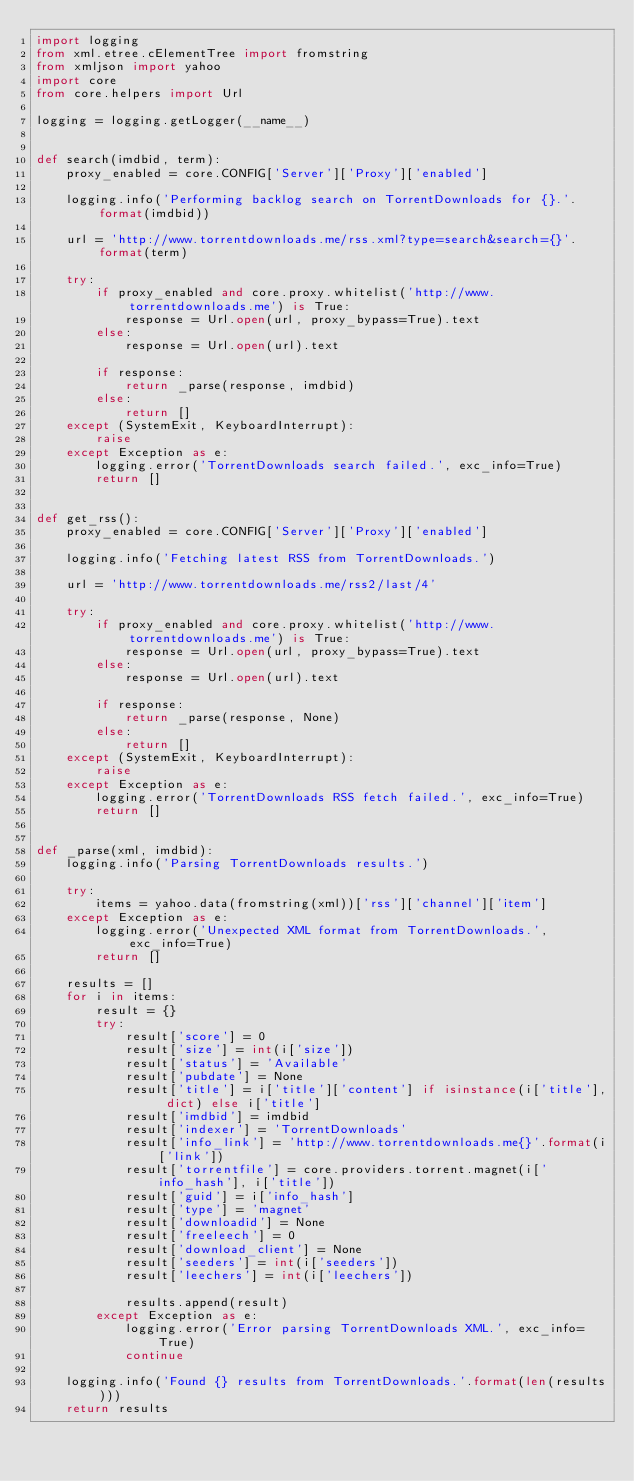<code> <loc_0><loc_0><loc_500><loc_500><_Python_>import logging
from xml.etree.cElementTree import fromstring
from xmljson import yahoo
import core
from core.helpers import Url

logging = logging.getLogger(__name__)


def search(imdbid, term):
    proxy_enabled = core.CONFIG['Server']['Proxy']['enabled']

    logging.info('Performing backlog search on TorrentDownloads for {}.'.format(imdbid))

    url = 'http://www.torrentdownloads.me/rss.xml?type=search&search={}'.format(term)

    try:
        if proxy_enabled and core.proxy.whitelist('http://www.torrentdownloads.me') is True:
            response = Url.open(url, proxy_bypass=True).text
        else:
            response = Url.open(url).text

        if response:
            return _parse(response, imdbid)
        else:
            return []
    except (SystemExit, KeyboardInterrupt):
        raise
    except Exception as e:
        logging.error('TorrentDownloads search failed.', exc_info=True)
        return []


def get_rss():
    proxy_enabled = core.CONFIG['Server']['Proxy']['enabled']

    logging.info('Fetching latest RSS from TorrentDownloads.')

    url = 'http://www.torrentdownloads.me/rss2/last/4'

    try:
        if proxy_enabled and core.proxy.whitelist('http://www.torrentdownloads.me') is True:
            response = Url.open(url, proxy_bypass=True).text
        else:
            response = Url.open(url).text

        if response:
            return _parse(response, None)
        else:
            return []
    except (SystemExit, KeyboardInterrupt):
        raise
    except Exception as e:
        logging.error('TorrentDownloads RSS fetch failed.', exc_info=True)
        return []


def _parse(xml, imdbid):
    logging.info('Parsing TorrentDownloads results.')

    try:
        items = yahoo.data(fromstring(xml))['rss']['channel']['item']
    except Exception as e:
        logging.error('Unexpected XML format from TorrentDownloads.', exc_info=True)
        return []

    results = []
    for i in items:
        result = {}
        try:
            result['score'] = 0
            result['size'] = int(i['size'])
            result['status'] = 'Available'
            result['pubdate'] = None
            result['title'] = i['title']['content'] if isinstance(i['title'], dict) else i['title']
            result['imdbid'] = imdbid
            result['indexer'] = 'TorrentDownloads'
            result['info_link'] = 'http://www.torrentdownloads.me{}'.format(i['link'])
            result['torrentfile'] = core.providers.torrent.magnet(i['info_hash'], i['title'])
            result['guid'] = i['info_hash']
            result['type'] = 'magnet'
            result['downloadid'] = None
            result['freeleech'] = 0
            result['download_client'] = None
            result['seeders'] = int(i['seeders'])
            result['leechers'] = int(i['leechers'])

            results.append(result)
        except Exception as e:
            logging.error('Error parsing TorrentDownloads XML.', exc_info=True)
            continue

    logging.info('Found {} results from TorrentDownloads.'.format(len(results)))
    return results
</code> 